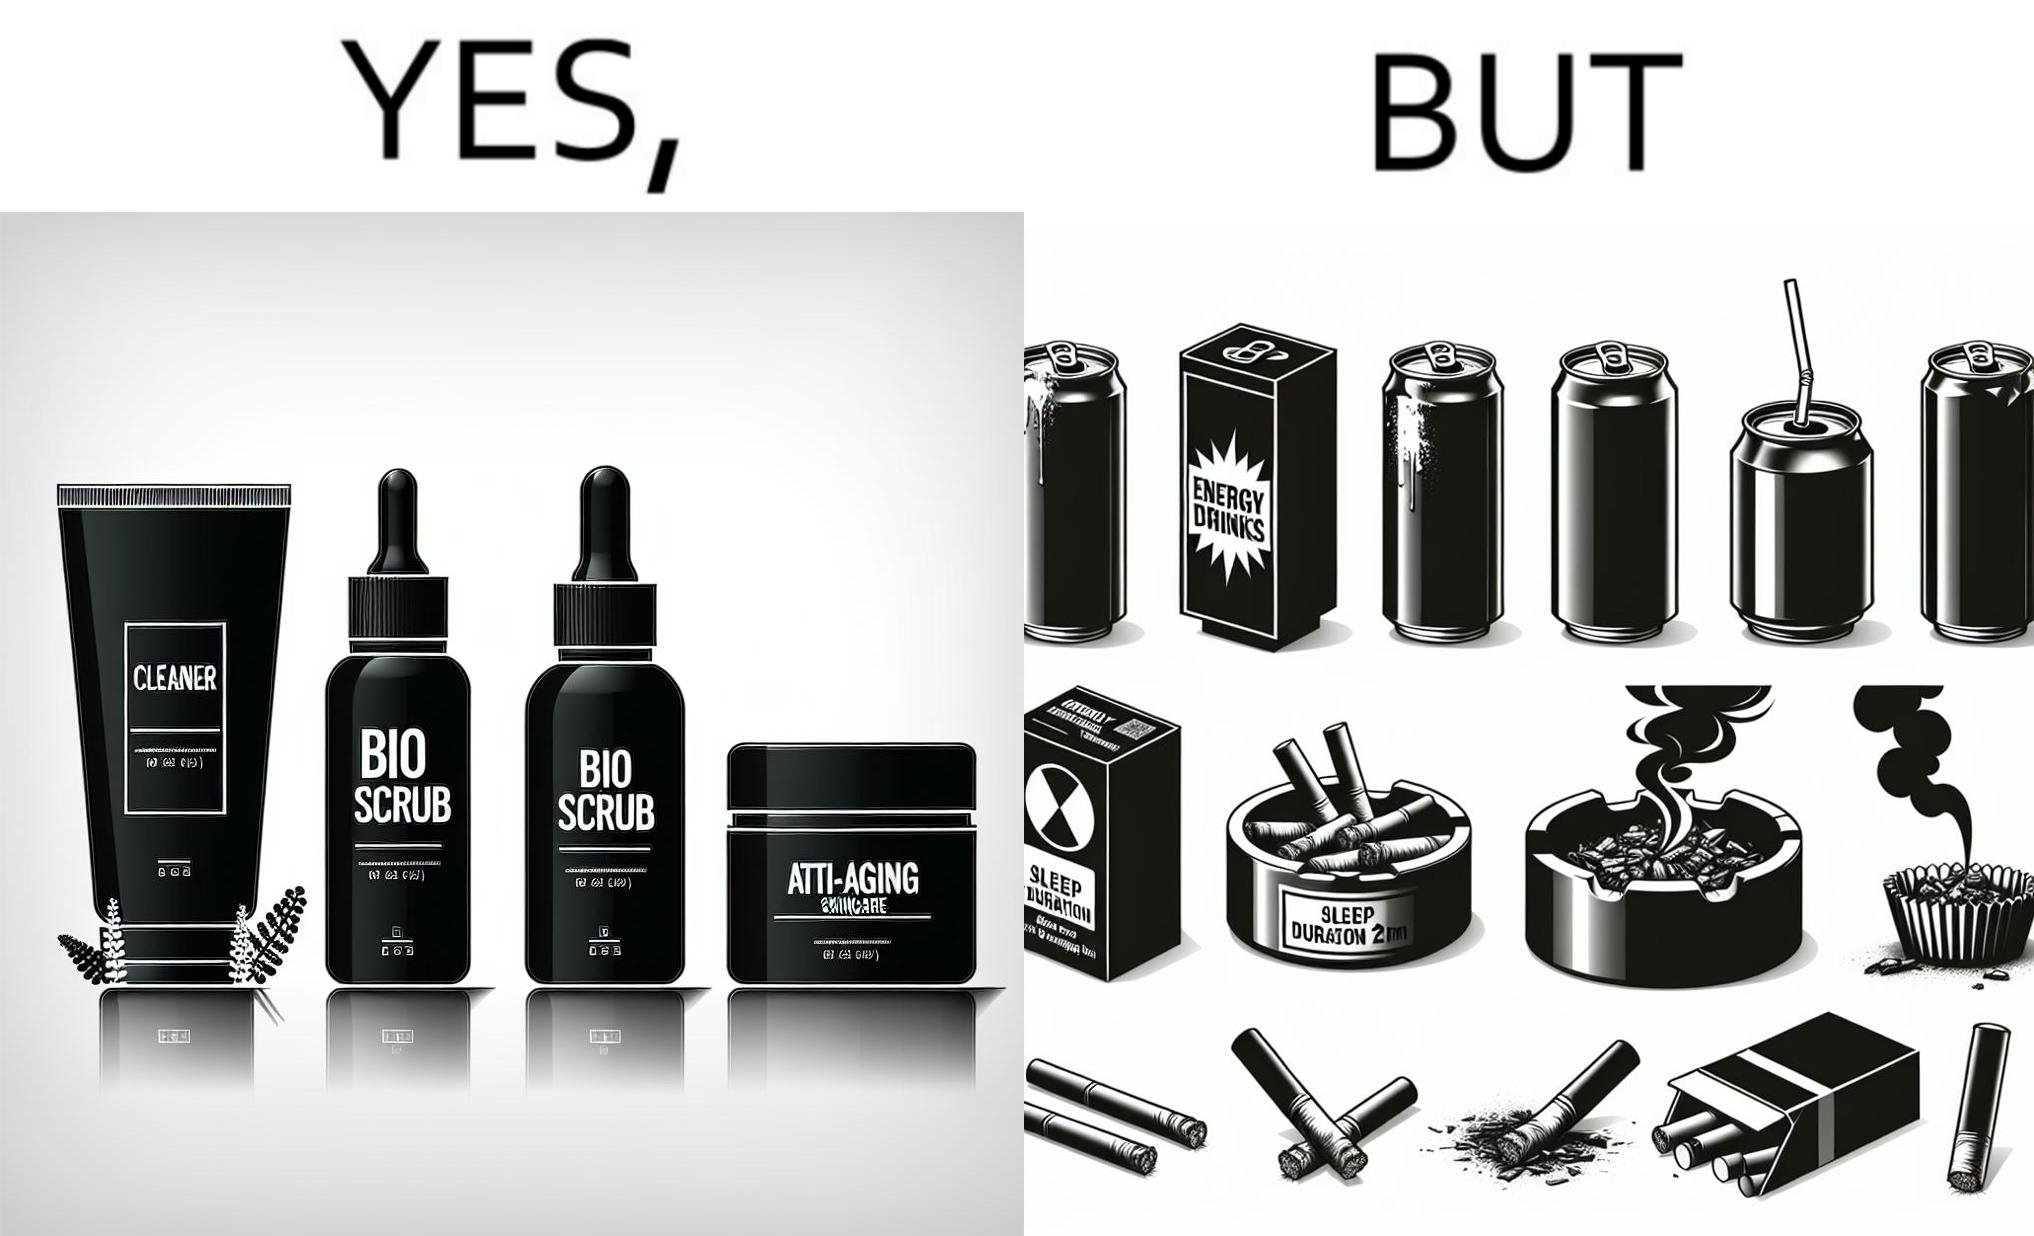Is this a satirical image? Yes, this image is satirical. 